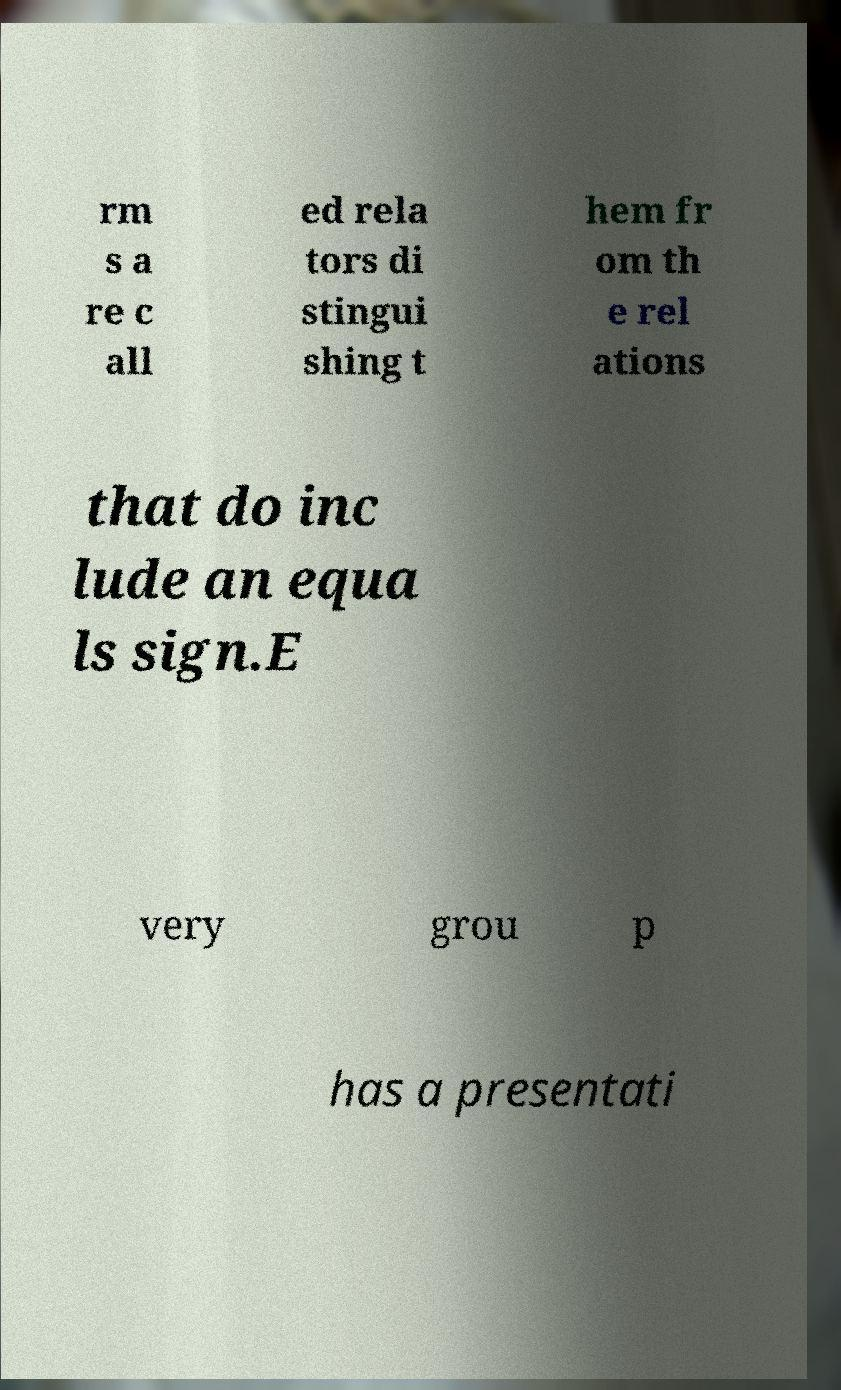Could you assist in decoding the text presented in this image and type it out clearly? rm s a re c all ed rela tors di stingui shing t hem fr om th e rel ations that do inc lude an equa ls sign.E very grou p has a presentati 